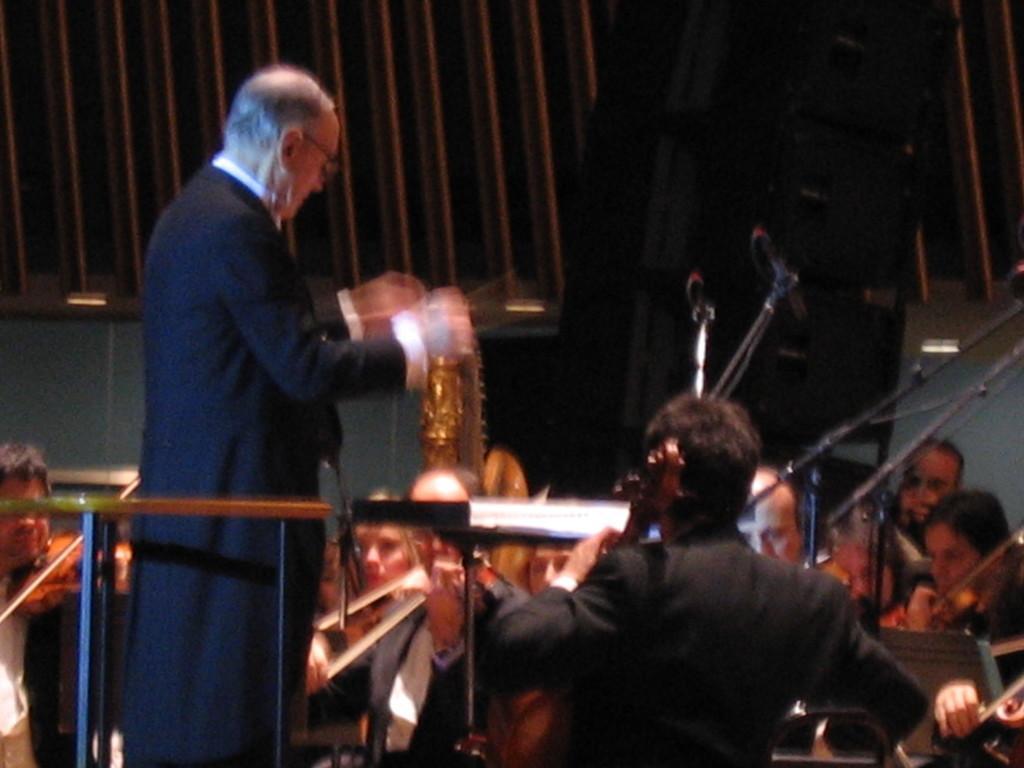Can you describe this image briefly? In the image we can see there are people sitting and one is standing, they are wearing clothes. We can even see microphones and musical instruments. 